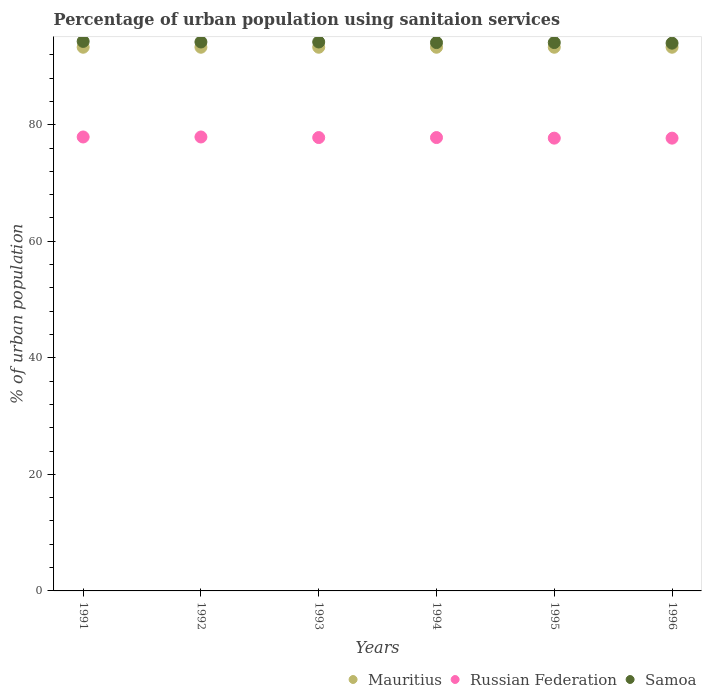What is the percentage of urban population using sanitaion services in Mauritius in 1995?
Ensure brevity in your answer.  93.3. Across all years, what is the maximum percentage of urban population using sanitaion services in Mauritius?
Your response must be concise. 93.3. Across all years, what is the minimum percentage of urban population using sanitaion services in Mauritius?
Provide a short and direct response. 93.3. In which year was the percentage of urban population using sanitaion services in Mauritius minimum?
Give a very brief answer. 1991. What is the total percentage of urban population using sanitaion services in Mauritius in the graph?
Ensure brevity in your answer.  559.8. What is the difference between the percentage of urban population using sanitaion services in Russian Federation in 1995 and that in 1996?
Offer a terse response. 0. What is the difference between the percentage of urban population using sanitaion services in Samoa in 1993 and the percentage of urban population using sanitaion services in Mauritius in 1991?
Provide a succinct answer. 0.9. What is the average percentage of urban population using sanitaion services in Samoa per year?
Keep it short and to the point. 94.15. In the year 1991, what is the difference between the percentage of urban population using sanitaion services in Mauritius and percentage of urban population using sanitaion services in Samoa?
Offer a terse response. -1. In how many years, is the percentage of urban population using sanitaion services in Russian Federation greater than 80 %?
Your answer should be very brief. 0. Is the percentage of urban population using sanitaion services in Russian Federation in 1991 less than that in 1993?
Keep it short and to the point. No. What is the difference between the highest and the second highest percentage of urban population using sanitaion services in Samoa?
Your answer should be compact. 0.1. What is the difference between the highest and the lowest percentage of urban population using sanitaion services in Samoa?
Offer a terse response. 0.3. Is the sum of the percentage of urban population using sanitaion services in Samoa in 1993 and 1994 greater than the maximum percentage of urban population using sanitaion services in Russian Federation across all years?
Offer a very short reply. Yes. How many dotlines are there?
Make the answer very short. 3. What is the difference between two consecutive major ticks on the Y-axis?
Your response must be concise. 20. Does the graph contain any zero values?
Provide a succinct answer. No. Does the graph contain grids?
Offer a terse response. No. Where does the legend appear in the graph?
Provide a short and direct response. Bottom right. How are the legend labels stacked?
Your answer should be very brief. Horizontal. What is the title of the graph?
Provide a short and direct response. Percentage of urban population using sanitaion services. What is the label or title of the Y-axis?
Your answer should be compact. % of urban population. What is the % of urban population of Mauritius in 1991?
Your answer should be very brief. 93.3. What is the % of urban population of Russian Federation in 1991?
Keep it short and to the point. 77.9. What is the % of urban population in Samoa in 1991?
Provide a succinct answer. 94.3. What is the % of urban population of Mauritius in 1992?
Make the answer very short. 93.3. What is the % of urban population in Russian Federation in 1992?
Your answer should be compact. 77.9. What is the % of urban population of Samoa in 1992?
Your answer should be very brief. 94.2. What is the % of urban population of Mauritius in 1993?
Offer a terse response. 93.3. What is the % of urban population in Russian Federation in 1993?
Offer a terse response. 77.8. What is the % of urban population of Samoa in 1993?
Provide a short and direct response. 94.2. What is the % of urban population of Mauritius in 1994?
Keep it short and to the point. 93.3. What is the % of urban population in Russian Federation in 1994?
Your answer should be very brief. 77.8. What is the % of urban population of Samoa in 1994?
Ensure brevity in your answer.  94.1. What is the % of urban population of Mauritius in 1995?
Offer a terse response. 93.3. What is the % of urban population of Russian Federation in 1995?
Your response must be concise. 77.7. What is the % of urban population of Samoa in 1995?
Provide a short and direct response. 94.1. What is the % of urban population of Mauritius in 1996?
Keep it short and to the point. 93.3. What is the % of urban population in Russian Federation in 1996?
Give a very brief answer. 77.7. What is the % of urban population in Samoa in 1996?
Offer a very short reply. 94. Across all years, what is the maximum % of urban population of Mauritius?
Your answer should be very brief. 93.3. Across all years, what is the maximum % of urban population in Russian Federation?
Provide a succinct answer. 77.9. Across all years, what is the maximum % of urban population of Samoa?
Offer a terse response. 94.3. Across all years, what is the minimum % of urban population in Mauritius?
Keep it short and to the point. 93.3. Across all years, what is the minimum % of urban population in Russian Federation?
Provide a succinct answer. 77.7. Across all years, what is the minimum % of urban population of Samoa?
Make the answer very short. 94. What is the total % of urban population of Mauritius in the graph?
Give a very brief answer. 559.8. What is the total % of urban population of Russian Federation in the graph?
Your answer should be compact. 466.8. What is the total % of urban population of Samoa in the graph?
Your answer should be compact. 564.9. What is the difference between the % of urban population in Mauritius in 1991 and that in 1992?
Give a very brief answer. 0. What is the difference between the % of urban population in Samoa in 1991 and that in 1992?
Provide a succinct answer. 0.1. What is the difference between the % of urban population in Russian Federation in 1991 and that in 1993?
Ensure brevity in your answer.  0.1. What is the difference between the % of urban population of Mauritius in 1991 and that in 1996?
Offer a terse response. 0. What is the difference between the % of urban population in Samoa in 1991 and that in 1996?
Your response must be concise. 0.3. What is the difference between the % of urban population of Russian Federation in 1992 and that in 1993?
Give a very brief answer. 0.1. What is the difference between the % of urban population in Samoa in 1992 and that in 1993?
Make the answer very short. 0. What is the difference between the % of urban population in Mauritius in 1992 and that in 1994?
Your answer should be very brief. 0. What is the difference between the % of urban population in Samoa in 1992 and that in 1994?
Provide a short and direct response. 0.1. What is the difference between the % of urban population in Samoa in 1992 and that in 1995?
Offer a very short reply. 0.1. What is the difference between the % of urban population in Mauritius in 1992 and that in 1996?
Your answer should be very brief. 0. What is the difference between the % of urban population in Samoa in 1992 and that in 1996?
Ensure brevity in your answer.  0.2. What is the difference between the % of urban population of Russian Federation in 1993 and that in 1994?
Make the answer very short. 0. What is the difference between the % of urban population of Samoa in 1993 and that in 1994?
Provide a short and direct response. 0.1. What is the difference between the % of urban population of Mauritius in 1993 and that in 1995?
Offer a terse response. 0. What is the difference between the % of urban population in Russian Federation in 1993 and that in 1995?
Offer a terse response. 0.1. What is the difference between the % of urban population of Samoa in 1993 and that in 1995?
Ensure brevity in your answer.  0.1. What is the difference between the % of urban population of Samoa in 1993 and that in 1996?
Provide a short and direct response. 0.2. What is the difference between the % of urban population of Mauritius in 1994 and that in 1995?
Your answer should be compact. 0. What is the difference between the % of urban population in Samoa in 1994 and that in 1995?
Keep it short and to the point. 0. What is the difference between the % of urban population in Mauritius in 1994 and that in 1996?
Give a very brief answer. 0. What is the difference between the % of urban population of Samoa in 1994 and that in 1996?
Your answer should be compact. 0.1. What is the difference between the % of urban population of Mauritius in 1991 and the % of urban population of Samoa in 1992?
Provide a short and direct response. -0.9. What is the difference between the % of urban population in Russian Federation in 1991 and the % of urban population in Samoa in 1992?
Your answer should be compact. -16.3. What is the difference between the % of urban population of Mauritius in 1991 and the % of urban population of Samoa in 1993?
Provide a succinct answer. -0.9. What is the difference between the % of urban population in Russian Federation in 1991 and the % of urban population in Samoa in 1993?
Your response must be concise. -16.3. What is the difference between the % of urban population of Mauritius in 1991 and the % of urban population of Russian Federation in 1994?
Keep it short and to the point. 15.5. What is the difference between the % of urban population in Mauritius in 1991 and the % of urban population in Samoa in 1994?
Offer a very short reply. -0.8. What is the difference between the % of urban population of Russian Federation in 1991 and the % of urban population of Samoa in 1994?
Make the answer very short. -16.2. What is the difference between the % of urban population of Mauritius in 1991 and the % of urban population of Russian Federation in 1995?
Give a very brief answer. 15.6. What is the difference between the % of urban population in Russian Federation in 1991 and the % of urban population in Samoa in 1995?
Your answer should be compact. -16.2. What is the difference between the % of urban population of Mauritius in 1991 and the % of urban population of Russian Federation in 1996?
Offer a very short reply. 15.6. What is the difference between the % of urban population in Mauritius in 1991 and the % of urban population in Samoa in 1996?
Your response must be concise. -0.7. What is the difference between the % of urban population in Russian Federation in 1991 and the % of urban population in Samoa in 1996?
Offer a terse response. -16.1. What is the difference between the % of urban population in Russian Federation in 1992 and the % of urban population in Samoa in 1993?
Your response must be concise. -16.3. What is the difference between the % of urban population in Mauritius in 1992 and the % of urban population in Russian Federation in 1994?
Make the answer very short. 15.5. What is the difference between the % of urban population of Russian Federation in 1992 and the % of urban population of Samoa in 1994?
Your answer should be very brief. -16.2. What is the difference between the % of urban population of Mauritius in 1992 and the % of urban population of Russian Federation in 1995?
Give a very brief answer. 15.6. What is the difference between the % of urban population in Mauritius in 1992 and the % of urban population in Samoa in 1995?
Your answer should be compact. -0.8. What is the difference between the % of urban population in Russian Federation in 1992 and the % of urban population in Samoa in 1995?
Give a very brief answer. -16.2. What is the difference between the % of urban population of Mauritius in 1992 and the % of urban population of Russian Federation in 1996?
Give a very brief answer. 15.6. What is the difference between the % of urban population of Russian Federation in 1992 and the % of urban population of Samoa in 1996?
Give a very brief answer. -16.1. What is the difference between the % of urban population of Mauritius in 1993 and the % of urban population of Russian Federation in 1994?
Make the answer very short. 15.5. What is the difference between the % of urban population in Russian Federation in 1993 and the % of urban population in Samoa in 1994?
Ensure brevity in your answer.  -16.3. What is the difference between the % of urban population in Mauritius in 1993 and the % of urban population in Samoa in 1995?
Provide a succinct answer. -0.8. What is the difference between the % of urban population in Russian Federation in 1993 and the % of urban population in Samoa in 1995?
Keep it short and to the point. -16.3. What is the difference between the % of urban population in Mauritius in 1993 and the % of urban population in Samoa in 1996?
Make the answer very short. -0.7. What is the difference between the % of urban population in Russian Federation in 1993 and the % of urban population in Samoa in 1996?
Keep it short and to the point. -16.2. What is the difference between the % of urban population of Russian Federation in 1994 and the % of urban population of Samoa in 1995?
Your answer should be compact. -16.3. What is the difference between the % of urban population of Mauritius in 1994 and the % of urban population of Russian Federation in 1996?
Keep it short and to the point. 15.6. What is the difference between the % of urban population of Mauritius in 1994 and the % of urban population of Samoa in 1996?
Your response must be concise. -0.7. What is the difference between the % of urban population of Russian Federation in 1994 and the % of urban population of Samoa in 1996?
Keep it short and to the point. -16.2. What is the difference between the % of urban population in Mauritius in 1995 and the % of urban population in Russian Federation in 1996?
Ensure brevity in your answer.  15.6. What is the difference between the % of urban population in Russian Federation in 1995 and the % of urban population in Samoa in 1996?
Make the answer very short. -16.3. What is the average % of urban population in Mauritius per year?
Keep it short and to the point. 93.3. What is the average % of urban population in Russian Federation per year?
Offer a very short reply. 77.8. What is the average % of urban population in Samoa per year?
Give a very brief answer. 94.15. In the year 1991, what is the difference between the % of urban population of Mauritius and % of urban population of Russian Federation?
Ensure brevity in your answer.  15.4. In the year 1991, what is the difference between the % of urban population in Mauritius and % of urban population in Samoa?
Offer a terse response. -1. In the year 1991, what is the difference between the % of urban population in Russian Federation and % of urban population in Samoa?
Ensure brevity in your answer.  -16.4. In the year 1992, what is the difference between the % of urban population in Mauritius and % of urban population in Russian Federation?
Offer a terse response. 15.4. In the year 1992, what is the difference between the % of urban population in Russian Federation and % of urban population in Samoa?
Keep it short and to the point. -16.3. In the year 1993, what is the difference between the % of urban population of Mauritius and % of urban population of Russian Federation?
Keep it short and to the point. 15.5. In the year 1993, what is the difference between the % of urban population in Russian Federation and % of urban population in Samoa?
Give a very brief answer. -16.4. In the year 1994, what is the difference between the % of urban population of Mauritius and % of urban population of Russian Federation?
Provide a succinct answer. 15.5. In the year 1994, what is the difference between the % of urban population of Mauritius and % of urban population of Samoa?
Provide a succinct answer. -0.8. In the year 1994, what is the difference between the % of urban population of Russian Federation and % of urban population of Samoa?
Provide a succinct answer. -16.3. In the year 1995, what is the difference between the % of urban population of Russian Federation and % of urban population of Samoa?
Provide a succinct answer. -16.4. In the year 1996, what is the difference between the % of urban population of Russian Federation and % of urban population of Samoa?
Your answer should be compact. -16.3. What is the ratio of the % of urban population of Samoa in 1991 to that in 1992?
Offer a very short reply. 1. What is the ratio of the % of urban population of Mauritius in 1991 to that in 1993?
Provide a succinct answer. 1. What is the ratio of the % of urban population of Russian Federation in 1991 to that in 1993?
Offer a terse response. 1. What is the ratio of the % of urban population of Mauritius in 1991 to that in 1994?
Your answer should be compact. 1. What is the ratio of the % of urban population in Mauritius in 1991 to that in 1995?
Give a very brief answer. 1. What is the ratio of the % of urban population of Russian Federation in 1992 to that in 1993?
Provide a short and direct response. 1. What is the ratio of the % of urban population in Samoa in 1992 to that in 1993?
Keep it short and to the point. 1. What is the ratio of the % of urban population in Samoa in 1992 to that in 1994?
Your answer should be compact. 1. What is the ratio of the % of urban population in Russian Federation in 1992 to that in 1995?
Make the answer very short. 1. What is the ratio of the % of urban population in Russian Federation in 1992 to that in 1996?
Your response must be concise. 1. What is the ratio of the % of urban population of Russian Federation in 1993 to that in 1994?
Offer a very short reply. 1. What is the ratio of the % of urban population of Samoa in 1993 to that in 1994?
Provide a succinct answer. 1. What is the ratio of the % of urban population in Mauritius in 1993 to that in 1995?
Your response must be concise. 1. What is the ratio of the % of urban population in Russian Federation in 1993 to that in 1995?
Offer a very short reply. 1. What is the ratio of the % of urban population in Samoa in 1993 to that in 1995?
Your answer should be compact. 1. What is the ratio of the % of urban population in Samoa in 1993 to that in 1996?
Ensure brevity in your answer.  1. What is the ratio of the % of urban population of Mauritius in 1994 to that in 1995?
Provide a succinct answer. 1. What is the ratio of the % of urban population in Samoa in 1994 to that in 1995?
Your answer should be compact. 1. What is the ratio of the % of urban population of Mauritius in 1994 to that in 1996?
Give a very brief answer. 1. What is the ratio of the % of urban population of Russian Federation in 1994 to that in 1996?
Your answer should be very brief. 1. What is the ratio of the % of urban population of Samoa in 1994 to that in 1996?
Provide a short and direct response. 1. What is the ratio of the % of urban population of Russian Federation in 1995 to that in 1996?
Offer a terse response. 1. What is the difference between the highest and the second highest % of urban population of Mauritius?
Your answer should be compact. 0. What is the difference between the highest and the second highest % of urban population of Samoa?
Keep it short and to the point. 0.1. What is the difference between the highest and the lowest % of urban population of Russian Federation?
Provide a short and direct response. 0.2. 